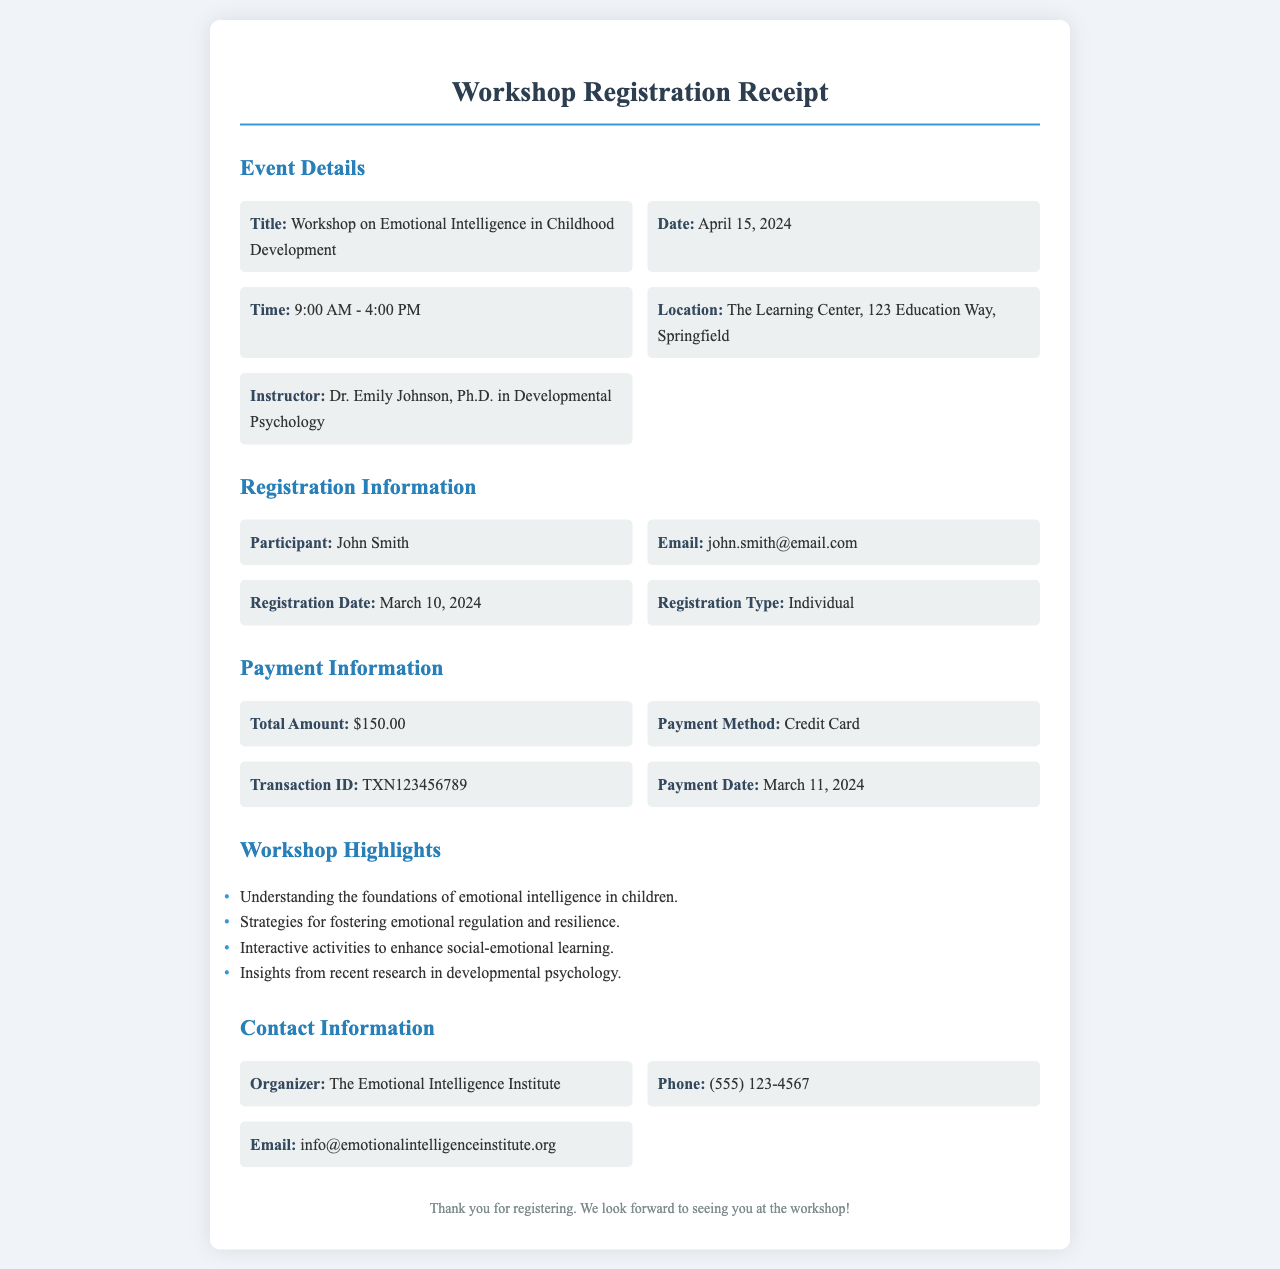What is the title of the workshop? The title of the workshop is specifically mentioned in the document under "Event Details."
Answer: Workshop on Emotional Intelligence in Childhood Development What is the date of the seminar? The date is outlined in the "Event Details" section of the receipt.
Answer: April 15, 2024 Who is the instructor of the workshop? The instructor's name is provided in the "Event Details" section of the receipt.
Answer: Dr. Emily Johnson What is the total amount paid for registration? The total amount is specified in the "Payment Information" section of the receipt.
Answer: $150.00 When was the registration completed? The registration date is clearly indicated in the "Registration Information" section.
Answer: March 10, 2024 What is the payment method used? The method of payment is detailed in the "Payment Information" section of the receipt.
Answer: Credit Card What organization is hosting the workshop? The name of the organizer can be found in the "Contact Information" section.
Answer: The Emotional Intelligence Institute What are two highlights of the workshop? The highlights are detailed in a bulleted list; this asks for specific insights from that section.
Answer: Understanding the foundations of emotional intelligence in children; Strategies for fostering emotional regulation and resilience 